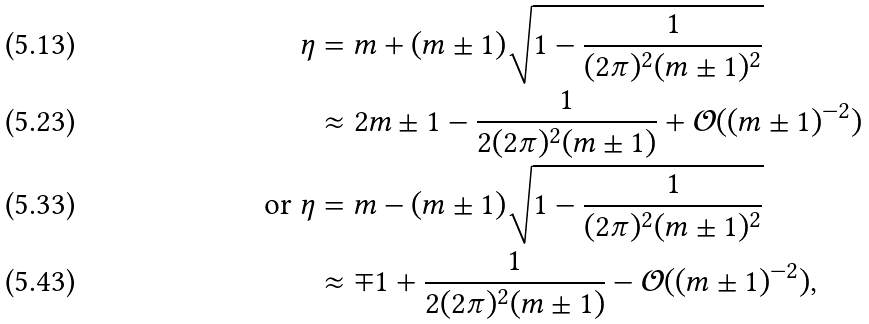<formula> <loc_0><loc_0><loc_500><loc_500>\eta & = m + ( m \pm 1 ) \sqrt { 1 - \frac { 1 } { ( 2 \pi ) ^ { 2 } ( m \pm 1 ) ^ { 2 } } } \\ & \approx 2 m \pm 1 - \frac { 1 } { 2 ( 2 \pi ) ^ { 2 } ( m \pm 1 ) } + \mathcal { O } ( ( m \pm 1 ) ^ { - 2 } ) \\ \text {or } \eta & = m - ( m \pm 1 ) \sqrt { 1 - \frac { 1 } { ( 2 \pi ) ^ { 2 } ( m \pm 1 ) ^ { 2 } } } \\ & \approx \mp 1 + \frac { 1 } { 2 ( 2 \pi ) ^ { 2 } ( m \pm 1 ) } - \mathcal { O } ( ( m \pm 1 ) ^ { - 2 } ) ,</formula> 